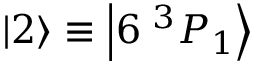<formula> <loc_0><loc_0><loc_500><loc_500>{ \left | 2 \right \rangle } \equiv { \left | 6 \, ^ { 3 } P _ { 1 } \right \rangle }</formula> 